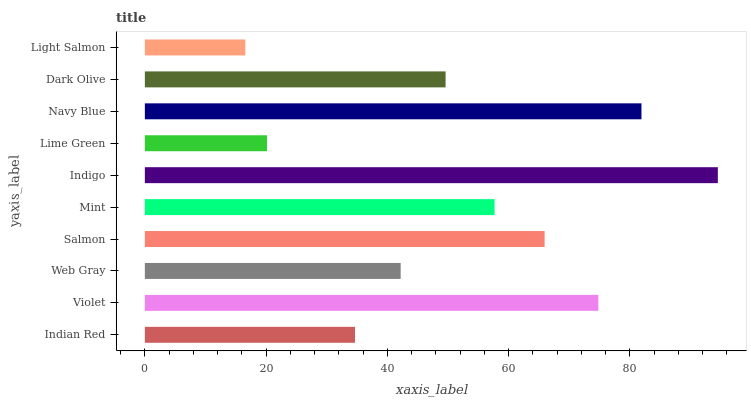Is Light Salmon the minimum?
Answer yes or no. Yes. Is Indigo the maximum?
Answer yes or no. Yes. Is Violet the minimum?
Answer yes or no. No. Is Violet the maximum?
Answer yes or no. No. Is Violet greater than Indian Red?
Answer yes or no. Yes. Is Indian Red less than Violet?
Answer yes or no. Yes. Is Indian Red greater than Violet?
Answer yes or no. No. Is Violet less than Indian Red?
Answer yes or no. No. Is Mint the high median?
Answer yes or no. Yes. Is Dark Olive the low median?
Answer yes or no. Yes. Is Dark Olive the high median?
Answer yes or no. No. Is Violet the low median?
Answer yes or no. No. 